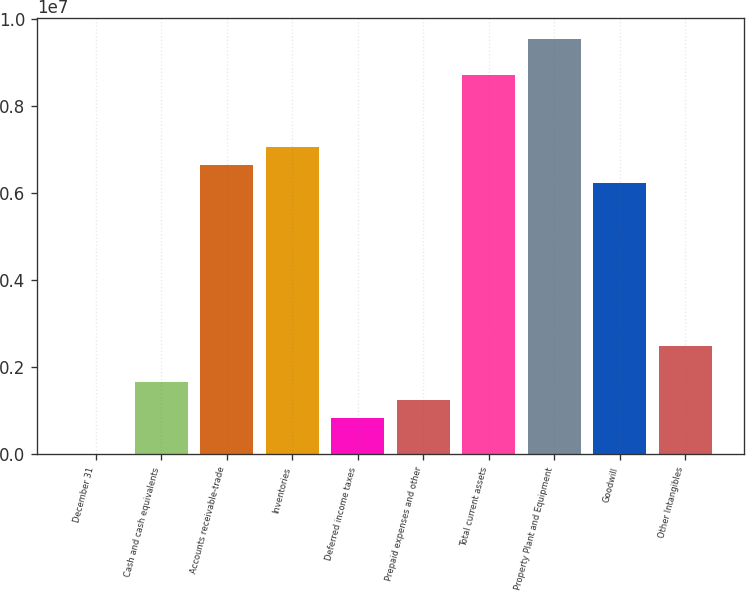<chart> <loc_0><loc_0><loc_500><loc_500><bar_chart><fcel>December 31<fcel>Cash and cash equivalents<fcel>Accounts receivable-trade<fcel>Inventories<fcel>Deferred income taxes<fcel>Prepaid expenses and other<fcel>Total current assets<fcel>Property Plant and Equipment<fcel>Goodwill<fcel>Other Intangibles<nl><fcel>2006<fcel>1.66423e+06<fcel>6.6509e+06<fcel>7.06646e+06<fcel>833118<fcel>1.24867e+06<fcel>8.72868e+06<fcel>9.55979e+06<fcel>6.23534e+06<fcel>2.49534e+06<nl></chart> 